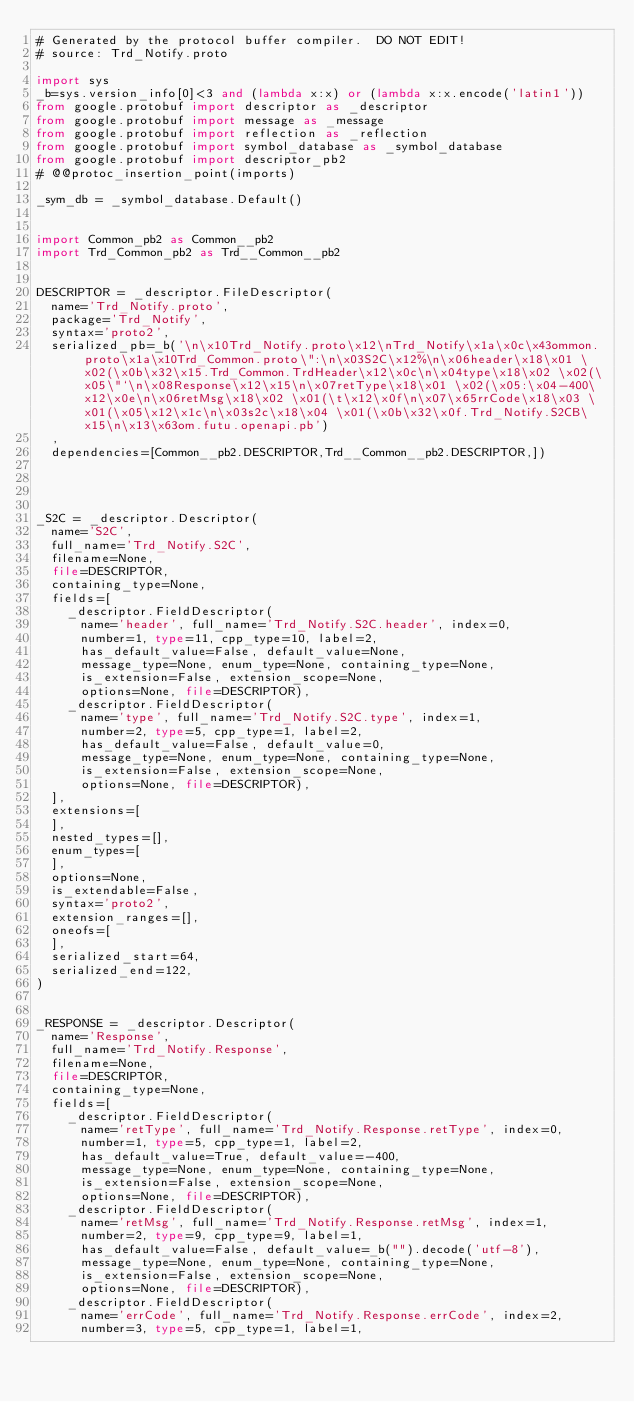Convert code to text. <code><loc_0><loc_0><loc_500><loc_500><_Python_># Generated by the protocol buffer compiler.  DO NOT EDIT!
# source: Trd_Notify.proto

import sys
_b=sys.version_info[0]<3 and (lambda x:x) or (lambda x:x.encode('latin1'))
from google.protobuf import descriptor as _descriptor
from google.protobuf import message as _message
from google.protobuf import reflection as _reflection
from google.protobuf import symbol_database as _symbol_database
from google.protobuf import descriptor_pb2
# @@protoc_insertion_point(imports)

_sym_db = _symbol_database.Default()


import Common_pb2 as Common__pb2
import Trd_Common_pb2 as Trd__Common__pb2


DESCRIPTOR = _descriptor.FileDescriptor(
  name='Trd_Notify.proto',
  package='Trd_Notify',
  syntax='proto2',
  serialized_pb=_b('\n\x10Trd_Notify.proto\x12\nTrd_Notify\x1a\x0c\x43ommon.proto\x1a\x10Trd_Common.proto\":\n\x03S2C\x12%\n\x06header\x18\x01 \x02(\x0b\x32\x15.Trd_Common.TrdHeader\x12\x0c\n\x04type\x18\x02 \x02(\x05\"`\n\x08Response\x12\x15\n\x07retType\x18\x01 \x02(\x05:\x04-400\x12\x0e\n\x06retMsg\x18\x02 \x01(\t\x12\x0f\n\x07\x65rrCode\x18\x03 \x01(\x05\x12\x1c\n\x03s2c\x18\x04 \x01(\x0b\x32\x0f.Trd_Notify.S2CB\x15\n\x13\x63om.futu.openapi.pb')
  ,
  dependencies=[Common__pb2.DESCRIPTOR,Trd__Common__pb2.DESCRIPTOR,])




_S2C = _descriptor.Descriptor(
  name='S2C',
  full_name='Trd_Notify.S2C',
  filename=None,
  file=DESCRIPTOR,
  containing_type=None,
  fields=[
    _descriptor.FieldDescriptor(
      name='header', full_name='Trd_Notify.S2C.header', index=0,
      number=1, type=11, cpp_type=10, label=2,
      has_default_value=False, default_value=None,
      message_type=None, enum_type=None, containing_type=None,
      is_extension=False, extension_scope=None,
      options=None, file=DESCRIPTOR),
    _descriptor.FieldDescriptor(
      name='type', full_name='Trd_Notify.S2C.type', index=1,
      number=2, type=5, cpp_type=1, label=2,
      has_default_value=False, default_value=0,
      message_type=None, enum_type=None, containing_type=None,
      is_extension=False, extension_scope=None,
      options=None, file=DESCRIPTOR),
  ],
  extensions=[
  ],
  nested_types=[],
  enum_types=[
  ],
  options=None,
  is_extendable=False,
  syntax='proto2',
  extension_ranges=[],
  oneofs=[
  ],
  serialized_start=64,
  serialized_end=122,
)


_RESPONSE = _descriptor.Descriptor(
  name='Response',
  full_name='Trd_Notify.Response',
  filename=None,
  file=DESCRIPTOR,
  containing_type=None,
  fields=[
    _descriptor.FieldDescriptor(
      name='retType', full_name='Trd_Notify.Response.retType', index=0,
      number=1, type=5, cpp_type=1, label=2,
      has_default_value=True, default_value=-400,
      message_type=None, enum_type=None, containing_type=None,
      is_extension=False, extension_scope=None,
      options=None, file=DESCRIPTOR),
    _descriptor.FieldDescriptor(
      name='retMsg', full_name='Trd_Notify.Response.retMsg', index=1,
      number=2, type=9, cpp_type=9, label=1,
      has_default_value=False, default_value=_b("").decode('utf-8'),
      message_type=None, enum_type=None, containing_type=None,
      is_extension=False, extension_scope=None,
      options=None, file=DESCRIPTOR),
    _descriptor.FieldDescriptor(
      name='errCode', full_name='Trd_Notify.Response.errCode', index=2,
      number=3, type=5, cpp_type=1, label=1,</code> 